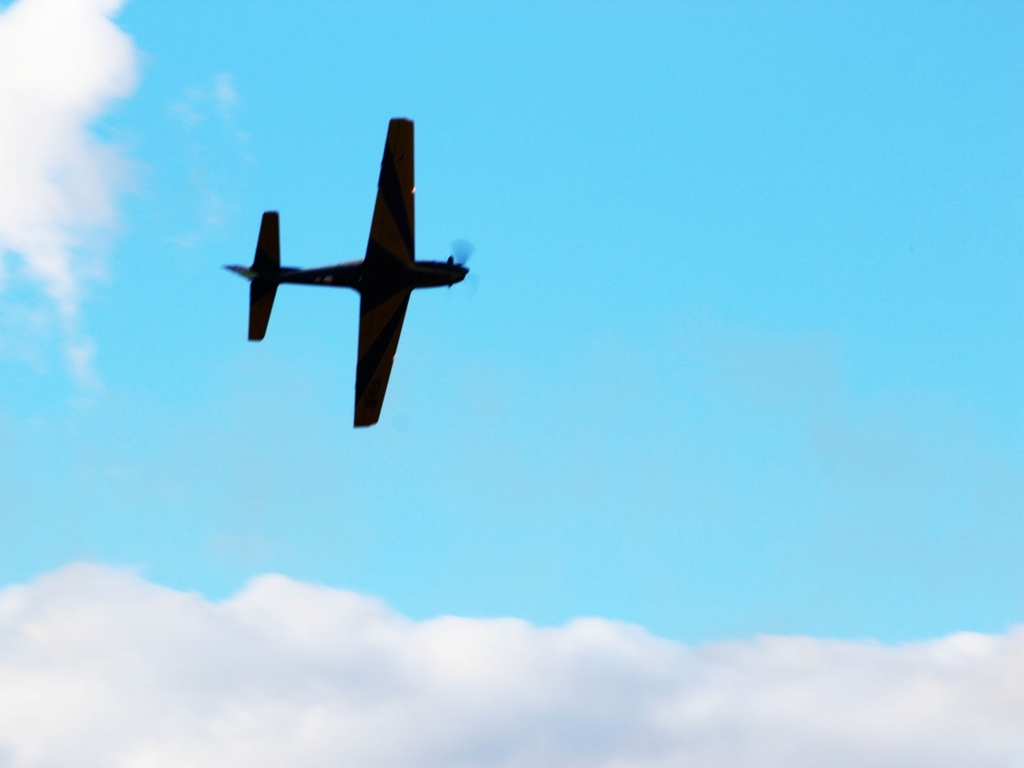Are the colors of the main subject vivid? Although the image depicts an aircraft against a bright sky, the colors of the main subject are not particularly vivid. The aircraft's color scheme appears to be muted and blends with the backdrop of the sky rather than standing out with highly saturated colors. Hence, the answer to whether the colors of the main subject are vivid would be no, they are not vivid. 